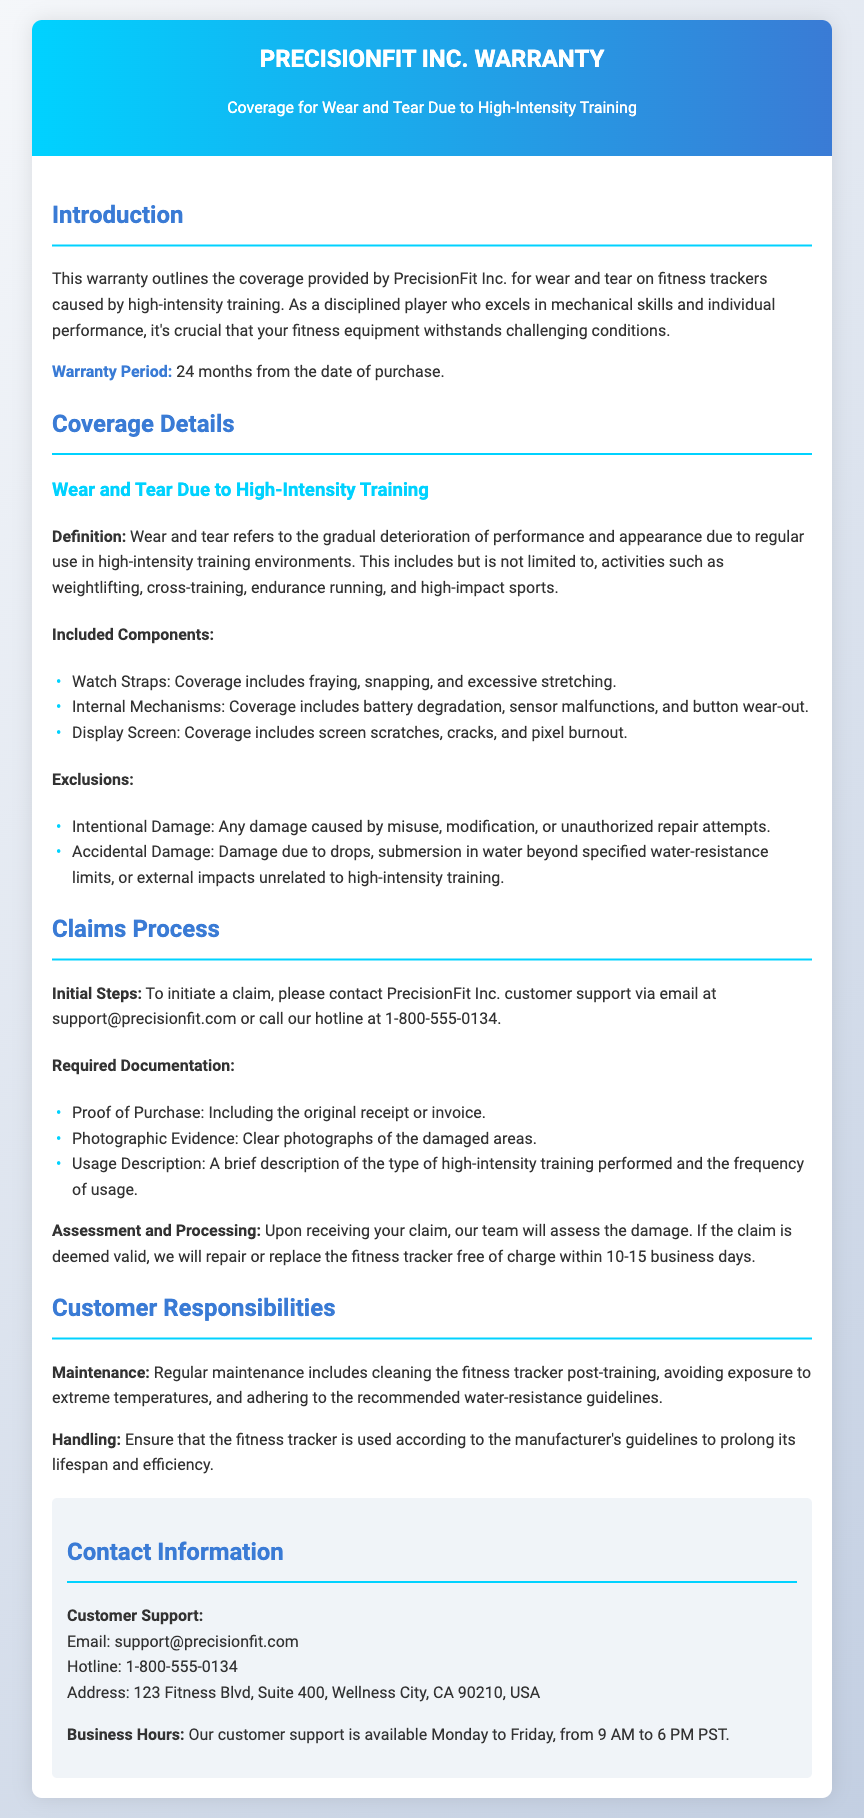What is the warranty period for the fitness tracker? The warranty period is stated in the document as lasting for 24 months from the date of purchase.
Answer: 24 months What types of damage are covered under "Included Components"? This refers to specific physical issues that the warranty addresses, detailed in the document's "Included Components" section.
Answer: Watch Straps, Internal Mechanisms, Display Screen What is required to initiate a claim? The document outlines initial steps for claiming, specifically mentioning contacting customer support.
Answer: Contact customer support Which types of damage are explicitly excluded? The document states specific damages that are not covered under the warranty.
Answer: Intentional Damage, Accidental Damage What documentation is needed to process a warranty claim? The list of required documents for a claim includes specific evidence as per the claims process section in the document.
Answer: Proof of Purchase, Photographic Evidence, Usage Description Why is regular maintenance important according to the warranty? Regular maintenance is emphasized to prolong the fitness tracker’s lifespan and efficiency, as highlighted in the customer responsibilities section.
Answer: To prolong lifespan and efficiency What is the contact email for PrecisionFit Inc. customer support? The document provides a specific email address to reach customer support for warranty inquiries.
Answer: support@precisionfit.com How long does the repair or replacement process take once a claim is valid? The document indicates a specific timeframe for the processing of valid warranty claims.
Answer: 10-15 business days 